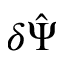<formula> <loc_0><loc_0><loc_500><loc_500>\delta \hat { \Psi }</formula> 